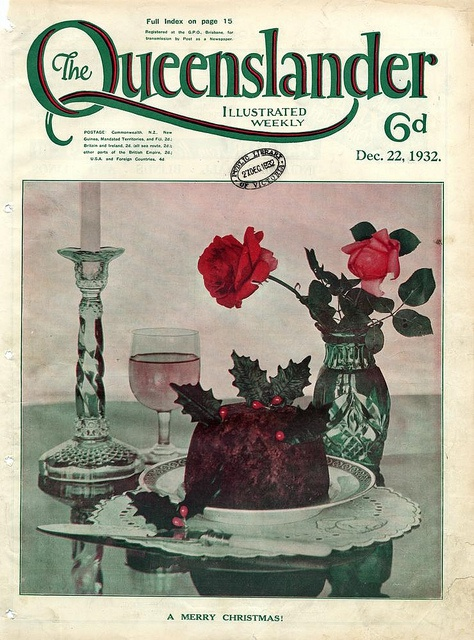Describe the objects in this image and their specific colors. I can see cake in white, black, maroon, gray, and darkgray tones, vase in white, gray, darkgray, and black tones, vase in white, black, gray, darkgray, and darkgreen tones, wine glass in white, darkgray, gray, and black tones, and bowl in white, darkgray, gray, and black tones in this image. 